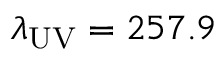Convert formula to latex. <formula><loc_0><loc_0><loc_500><loc_500>\lambda _ { U V } = 2 5 7 . 9</formula> 